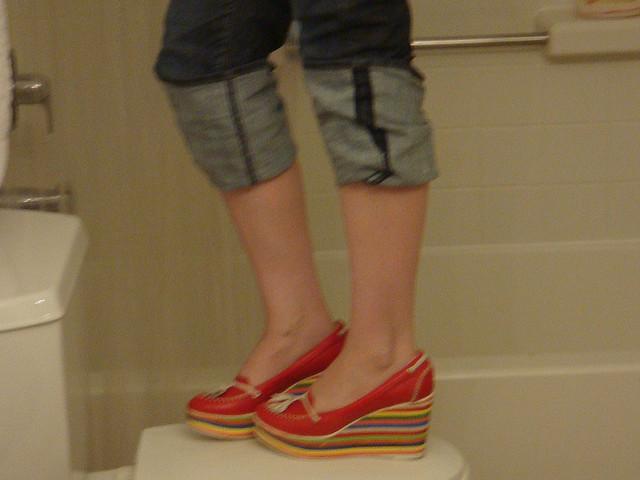What is she standing on?
Write a very short answer. Toilet. What is she preparing to make?
Be succinct. Nothing. Are these shoes a flat style?
Write a very short answer. No. What room is this?
Keep it brief. Bathroom. 